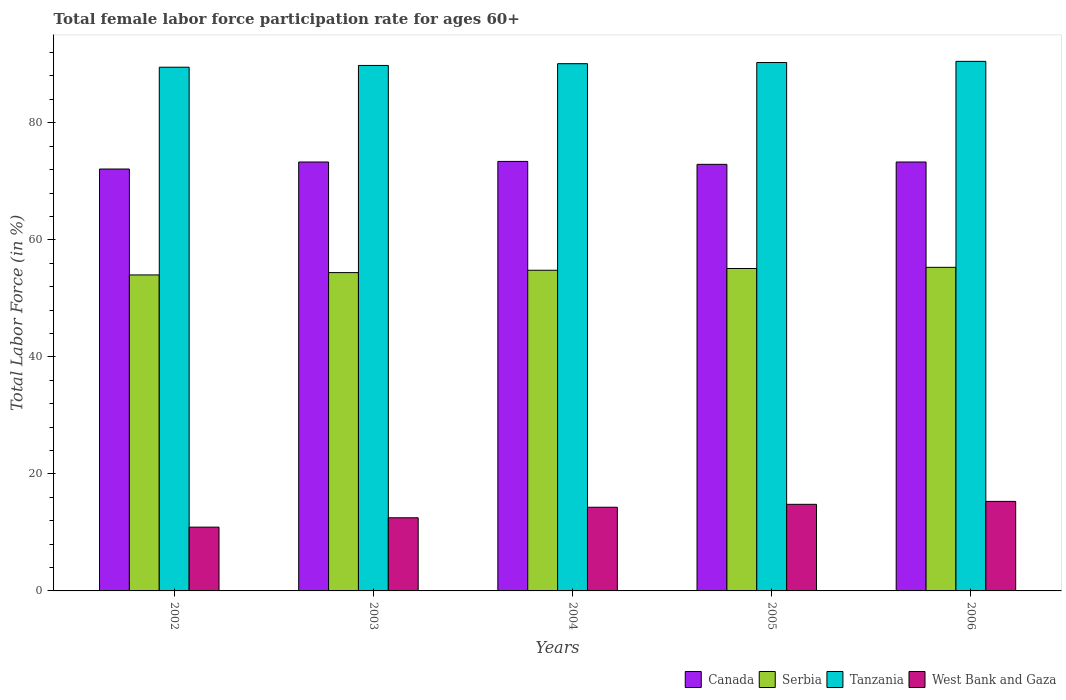How many different coloured bars are there?
Your answer should be very brief. 4. How many groups of bars are there?
Keep it short and to the point. 5. Are the number of bars per tick equal to the number of legend labels?
Provide a succinct answer. Yes. What is the label of the 2nd group of bars from the left?
Keep it short and to the point. 2003. What is the female labor force participation rate in Serbia in 2003?
Your answer should be compact. 54.4. Across all years, what is the maximum female labor force participation rate in Serbia?
Provide a short and direct response. 55.3. Across all years, what is the minimum female labor force participation rate in West Bank and Gaza?
Your response must be concise. 10.9. In which year was the female labor force participation rate in Canada maximum?
Make the answer very short. 2004. In which year was the female labor force participation rate in Serbia minimum?
Give a very brief answer. 2002. What is the total female labor force participation rate in West Bank and Gaza in the graph?
Make the answer very short. 67.8. What is the difference between the female labor force participation rate in West Bank and Gaza in 2004 and that in 2005?
Your response must be concise. -0.5. What is the difference between the female labor force participation rate in West Bank and Gaza in 2005 and the female labor force participation rate in Canada in 2004?
Ensure brevity in your answer.  -58.6. What is the average female labor force participation rate in Canada per year?
Offer a very short reply. 73. In the year 2005, what is the difference between the female labor force participation rate in Canada and female labor force participation rate in West Bank and Gaza?
Provide a succinct answer. 58.1. In how many years, is the female labor force participation rate in West Bank and Gaza greater than 88 %?
Provide a succinct answer. 0. What is the ratio of the female labor force participation rate in Serbia in 2003 to that in 2004?
Make the answer very short. 0.99. Is the difference between the female labor force participation rate in Canada in 2003 and 2005 greater than the difference between the female labor force participation rate in West Bank and Gaza in 2003 and 2005?
Keep it short and to the point. Yes. What is the difference between the highest and the second highest female labor force participation rate in Tanzania?
Make the answer very short. 0.2. What is the difference between the highest and the lowest female labor force participation rate in West Bank and Gaza?
Provide a succinct answer. 4.4. What does the 2nd bar from the left in 2002 represents?
Keep it short and to the point. Serbia. What does the 2nd bar from the right in 2006 represents?
Ensure brevity in your answer.  Tanzania. How many bars are there?
Your answer should be compact. 20. Are all the bars in the graph horizontal?
Your answer should be compact. No. How many years are there in the graph?
Provide a short and direct response. 5. Does the graph contain grids?
Offer a very short reply. No. What is the title of the graph?
Your answer should be very brief. Total female labor force participation rate for ages 60+. What is the label or title of the X-axis?
Your answer should be very brief. Years. What is the label or title of the Y-axis?
Your answer should be compact. Total Labor Force (in %). What is the Total Labor Force (in %) of Canada in 2002?
Your response must be concise. 72.1. What is the Total Labor Force (in %) of Serbia in 2002?
Your answer should be compact. 54. What is the Total Labor Force (in %) in Tanzania in 2002?
Ensure brevity in your answer.  89.5. What is the Total Labor Force (in %) in West Bank and Gaza in 2002?
Your response must be concise. 10.9. What is the Total Labor Force (in %) in Canada in 2003?
Your answer should be compact. 73.3. What is the Total Labor Force (in %) in Serbia in 2003?
Your answer should be compact. 54.4. What is the Total Labor Force (in %) of Tanzania in 2003?
Keep it short and to the point. 89.8. What is the Total Labor Force (in %) in West Bank and Gaza in 2003?
Make the answer very short. 12.5. What is the Total Labor Force (in %) of Canada in 2004?
Keep it short and to the point. 73.4. What is the Total Labor Force (in %) of Serbia in 2004?
Provide a short and direct response. 54.8. What is the Total Labor Force (in %) of Tanzania in 2004?
Make the answer very short. 90.1. What is the Total Labor Force (in %) in West Bank and Gaza in 2004?
Provide a short and direct response. 14.3. What is the Total Labor Force (in %) in Canada in 2005?
Keep it short and to the point. 72.9. What is the Total Labor Force (in %) of Serbia in 2005?
Offer a very short reply. 55.1. What is the Total Labor Force (in %) of Tanzania in 2005?
Keep it short and to the point. 90.3. What is the Total Labor Force (in %) of West Bank and Gaza in 2005?
Offer a terse response. 14.8. What is the Total Labor Force (in %) of Canada in 2006?
Your answer should be very brief. 73.3. What is the Total Labor Force (in %) in Serbia in 2006?
Make the answer very short. 55.3. What is the Total Labor Force (in %) in Tanzania in 2006?
Ensure brevity in your answer.  90.5. What is the Total Labor Force (in %) of West Bank and Gaza in 2006?
Ensure brevity in your answer.  15.3. Across all years, what is the maximum Total Labor Force (in %) of Canada?
Keep it short and to the point. 73.4. Across all years, what is the maximum Total Labor Force (in %) of Serbia?
Your answer should be very brief. 55.3. Across all years, what is the maximum Total Labor Force (in %) of Tanzania?
Offer a very short reply. 90.5. Across all years, what is the maximum Total Labor Force (in %) of West Bank and Gaza?
Provide a succinct answer. 15.3. Across all years, what is the minimum Total Labor Force (in %) in Canada?
Your response must be concise. 72.1. Across all years, what is the minimum Total Labor Force (in %) in Tanzania?
Your response must be concise. 89.5. Across all years, what is the minimum Total Labor Force (in %) of West Bank and Gaza?
Your response must be concise. 10.9. What is the total Total Labor Force (in %) in Canada in the graph?
Provide a short and direct response. 365. What is the total Total Labor Force (in %) in Serbia in the graph?
Provide a succinct answer. 273.6. What is the total Total Labor Force (in %) in Tanzania in the graph?
Provide a short and direct response. 450.2. What is the total Total Labor Force (in %) in West Bank and Gaza in the graph?
Your response must be concise. 67.8. What is the difference between the Total Labor Force (in %) in Tanzania in 2002 and that in 2003?
Make the answer very short. -0.3. What is the difference between the Total Labor Force (in %) in Serbia in 2002 and that in 2004?
Offer a terse response. -0.8. What is the difference between the Total Labor Force (in %) of West Bank and Gaza in 2002 and that in 2005?
Your response must be concise. -3.9. What is the difference between the Total Labor Force (in %) of Tanzania in 2002 and that in 2006?
Provide a succinct answer. -1. What is the difference between the Total Labor Force (in %) in West Bank and Gaza in 2002 and that in 2006?
Give a very brief answer. -4.4. What is the difference between the Total Labor Force (in %) in Canada in 2003 and that in 2004?
Give a very brief answer. -0.1. What is the difference between the Total Labor Force (in %) of Serbia in 2003 and that in 2004?
Make the answer very short. -0.4. What is the difference between the Total Labor Force (in %) of Canada in 2003 and that in 2005?
Make the answer very short. 0.4. What is the difference between the Total Labor Force (in %) in Serbia in 2003 and that in 2005?
Your answer should be compact. -0.7. What is the difference between the Total Labor Force (in %) of West Bank and Gaza in 2003 and that in 2006?
Provide a short and direct response. -2.8. What is the difference between the Total Labor Force (in %) in Canada in 2004 and that in 2005?
Keep it short and to the point. 0.5. What is the difference between the Total Labor Force (in %) in Tanzania in 2004 and that in 2005?
Keep it short and to the point. -0.2. What is the difference between the Total Labor Force (in %) in Serbia in 2004 and that in 2006?
Provide a short and direct response. -0.5. What is the difference between the Total Labor Force (in %) of Tanzania in 2004 and that in 2006?
Offer a very short reply. -0.4. What is the difference between the Total Labor Force (in %) of West Bank and Gaza in 2004 and that in 2006?
Your answer should be compact. -1. What is the difference between the Total Labor Force (in %) in Serbia in 2005 and that in 2006?
Offer a terse response. -0.2. What is the difference between the Total Labor Force (in %) in West Bank and Gaza in 2005 and that in 2006?
Offer a terse response. -0.5. What is the difference between the Total Labor Force (in %) of Canada in 2002 and the Total Labor Force (in %) of Tanzania in 2003?
Make the answer very short. -17.7. What is the difference between the Total Labor Force (in %) of Canada in 2002 and the Total Labor Force (in %) of West Bank and Gaza in 2003?
Offer a terse response. 59.6. What is the difference between the Total Labor Force (in %) of Serbia in 2002 and the Total Labor Force (in %) of Tanzania in 2003?
Your answer should be compact. -35.8. What is the difference between the Total Labor Force (in %) of Serbia in 2002 and the Total Labor Force (in %) of West Bank and Gaza in 2003?
Your answer should be very brief. 41.5. What is the difference between the Total Labor Force (in %) in Canada in 2002 and the Total Labor Force (in %) in Tanzania in 2004?
Give a very brief answer. -18. What is the difference between the Total Labor Force (in %) of Canada in 2002 and the Total Labor Force (in %) of West Bank and Gaza in 2004?
Your response must be concise. 57.8. What is the difference between the Total Labor Force (in %) of Serbia in 2002 and the Total Labor Force (in %) of Tanzania in 2004?
Your answer should be very brief. -36.1. What is the difference between the Total Labor Force (in %) in Serbia in 2002 and the Total Labor Force (in %) in West Bank and Gaza in 2004?
Your response must be concise. 39.7. What is the difference between the Total Labor Force (in %) of Tanzania in 2002 and the Total Labor Force (in %) of West Bank and Gaza in 2004?
Offer a terse response. 75.2. What is the difference between the Total Labor Force (in %) of Canada in 2002 and the Total Labor Force (in %) of Serbia in 2005?
Offer a terse response. 17. What is the difference between the Total Labor Force (in %) in Canada in 2002 and the Total Labor Force (in %) in Tanzania in 2005?
Your answer should be compact. -18.2. What is the difference between the Total Labor Force (in %) of Canada in 2002 and the Total Labor Force (in %) of West Bank and Gaza in 2005?
Provide a short and direct response. 57.3. What is the difference between the Total Labor Force (in %) of Serbia in 2002 and the Total Labor Force (in %) of Tanzania in 2005?
Your response must be concise. -36.3. What is the difference between the Total Labor Force (in %) of Serbia in 2002 and the Total Labor Force (in %) of West Bank and Gaza in 2005?
Keep it short and to the point. 39.2. What is the difference between the Total Labor Force (in %) of Tanzania in 2002 and the Total Labor Force (in %) of West Bank and Gaza in 2005?
Give a very brief answer. 74.7. What is the difference between the Total Labor Force (in %) of Canada in 2002 and the Total Labor Force (in %) of Tanzania in 2006?
Keep it short and to the point. -18.4. What is the difference between the Total Labor Force (in %) in Canada in 2002 and the Total Labor Force (in %) in West Bank and Gaza in 2006?
Your response must be concise. 56.8. What is the difference between the Total Labor Force (in %) in Serbia in 2002 and the Total Labor Force (in %) in Tanzania in 2006?
Your answer should be compact. -36.5. What is the difference between the Total Labor Force (in %) in Serbia in 2002 and the Total Labor Force (in %) in West Bank and Gaza in 2006?
Offer a terse response. 38.7. What is the difference between the Total Labor Force (in %) of Tanzania in 2002 and the Total Labor Force (in %) of West Bank and Gaza in 2006?
Ensure brevity in your answer.  74.2. What is the difference between the Total Labor Force (in %) of Canada in 2003 and the Total Labor Force (in %) of Serbia in 2004?
Make the answer very short. 18.5. What is the difference between the Total Labor Force (in %) in Canada in 2003 and the Total Labor Force (in %) in Tanzania in 2004?
Provide a succinct answer. -16.8. What is the difference between the Total Labor Force (in %) in Canada in 2003 and the Total Labor Force (in %) in West Bank and Gaza in 2004?
Ensure brevity in your answer.  59. What is the difference between the Total Labor Force (in %) in Serbia in 2003 and the Total Labor Force (in %) in Tanzania in 2004?
Make the answer very short. -35.7. What is the difference between the Total Labor Force (in %) of Serbia in 2003 and the Total Labor Force (in %) of West Bank and Gaza in 2004?
Your answer should be compact. 40.1. What is the difference between the Total Labor Force (in %) in Tanzania in 2003 and the Total Labor Force (in %) in West Bank and Gaza in 2004?
Ensure brevity in your answer.  75.5. What is the difference between the Total Labor Force (in %) in Canada in 2003 and the Total Labor Force (in %) in Serbia in 2005?
Provide a short and direct response. 18.2. What is the difference between the Total Labor Force (in %) in Canada in 2003 and the Total Labor Force (in %) in West Bank and Gaza in 2005?
Provide a short and direct response. 58.5. What is the difference between the Total Labor Force (in %) in Serbia in 2003 and the Total Labor Force (in %) in Tanzania in 2005?
Provide a succinct answer. -35.9. What is the difference between the Total Labor Force (in %) of Serbia in 2003 and the Total Labor Force (in %) of West Bank and Gaza in 2005?
Your response must be concise. 39.6. What is the difference between the Total Labor Force (in %) in Tanzania in 2003 and the Total Labor Force (in %) in West Bank and Gaza in 2005?
Offer a terse response. 75. What is the difference between the Total Labor Force (in %) in Canada in 2003 and the Total Labor Force (in %) in Tanzania in 2006?
Offer a very short reply. -17.2. What is the difference between the Total Labor Force (in %) of Serbia in 2003 and the Total Labor Force (in %) of Tanzania in 2006?
Keep it short and to the point. -36.1. What is the difference between the Total Labor Force (in %) of Serbia in 2003 and the Total Labor Force (in %) of West Bank and Gaza in 2006?
Give a very brief answer. 39.1. What is the difference between the Total Labor Force (in %) of Tanzania in 2003 and the Total Labor Force (in %) of West Bank and Gaza in 2006?
Make the answer very short. 74.5. What is the difference between the Total Labor Force (in %) of Canada in 2004 and the Total Labor Force (in %) of Serbia in 2005?
Your answer should be very brief. 18.3. What is the difference between the Total Labor Force (in %) of Canada in 2004 and the Total Labor Force (in %) of Tanzania in 2005?
Make the answer very short. -16.9. What is the difference between the Total Labor Force (in %) of Canada in 2004 and the Total Labor Force (in %) of West Bank and Gaza in 2005?
Give a very brief answer. 58.6. What is the difference between the Total Labor Force (in %) of Serbia in 2004 and the Total Labor Force (in %) of Tanzania in 2005?
Offer a terse response. -35.5. What is the difference between the Total Labor Force (in %) in Tanzania in 2004 and the Total Labor Force (in %) in West Bank and Gaza in 2005?
Offer a terse response. 75.3. What is the difference between the Total Labor Force (in %) in Canada in 2004 and the Total Labor Force (in %) in Tanzania in 2006?
Offer a terse response. -17.1. What is the difference between the Total Labor Force (in %) of Canada in 2004 and the Total Labor Force (in %) of West Bank and Gaza in 2006?
Your answer should be compact. 58.1. What is the difference between the Total Labor Force (in %) in Serbia in 2004 and the Total Labor Force (in %) in Tanzania in 2006?
Offer a very short reply. -35.7. What is the difference between the Total Labor Force (in %) in Serbia in 2004 and the Total Labor Force (in %) in West Bank and Gaza in 2006?
Your response must be concise. 39.5. What is the difference between the Total Labor Force (in %) in Tanzania in 2004 and the Total Labor Force (in %) in West Bank and Gaza in 2006?
Offer a very short reply. 74.8. What is the difference between the Total Labor Force (in %) in Canada in 2005 and the Total Labor Force (in %) in Tanzania in 2006?
Offer a terse response. -17.6. What is the difference between the Total Labor Force (in %) of Canada in 2005 and the Total Labor Force (in %) of West Bank and Gaza in 2006?
Your response must be concise. 57.6. What is the difference between the Total Labor Force (in %) of Serbia in 2005 and the Total Labor Force (in %) of Tanzania in 2006?
Offer a terse response. -35.4. What is the difference between the Total Labor Force (in %) in Serbia in 2005 and the Total Labor Force (in %) in West Bank and Gaza in 2006?
Make the answer very short. 39.8. What is the average Total Labor Force (in %) in Serbia per year?
Provide a succinct answer. 54.72. What is the average Total Labor Force (in %) in Tanzania per year?
Provide a succinct answer. 90.04. What is the average Total Labor Force (in %) in West Bank and Gaza per year?
Offer a terse response. 13.56. In the year 2002, what is the difference between the Total Labor Force (in %) of Canada and Total Labor Force (in %) of Tanzania?
Ensure brevity in your answer.  -17.4. In the year 2002, what is the difference between the Total Labor Force (in %) in Canada and Total Labor Force (in %) in West Bank and Gaza?
Offer a terse response. 61.2. In the year 2002, what is the difference between the Total Labor Force (in %) of Serbia and Total Labor Force (in %) of Tanzania?
Your response must be concise. -35.5. In the year 2002, what is the difference between the Total Labor Force (in %) of Serbia and Total Labor Force (in %) of West Bank and Gaza?
Offer a terse response. 43.1. In the year 2002, what is the difference between the Total Labor Force (in %) in Tanzania and Total Labor Force (in %) in West Bank and Gaza?
Your answer should be compact. 78.6. In the year 2003, what is the difference between the Total Labor Force (in %) of Canada and Total Labor Force (in %) of Serbia?
Provide a short and direct response. 18.9. In the year 2003, what is the difference between the Total Labor Force (in %) in Canada and Total Labor Force (in %) in Tanzania?
Keep it short and to the point. -16.5. In the year 2003, what is the difference between the Total Labor Force (in %) in Canada and Total Labor Force (in %) in West Bank and Gaza?
Offer a terse response. 60.8. In the year 2003, what is the difference between the Total Labor Force (in %) of Serbia and Total Labor Force (in %) of Tanzania?
Offer a very short reply. -35.4. In the year 2003, what is the difference between the Total Labor Force (in %) in Serbia and Total Labor Force (in %) in West Bank and Gaza?
Make the answer very short. 41.9. In the year 2003, what is the difference between the Total Labor Force (in %) in Tanzania and Total Labor Force (in %) in West Bank and Gaza?
Offer a terse response. 77.3. In the year 2004, what is the difference between the Total Labor Force (in %) in Canada and Total Labor Force (in %) in Serbia?
Offer a terse response. 18.6. In the year 2004, what is the difference between the Total Labor Force (in %) in Canada and Total Labor Force (in %) in Tanzania?
Your answer should be compact. -16.7. In the year 2004, what is the difference between the Total Labor Force (in %) in Canada and Total Labor Force (in %) in West Bank and Gaza?
Offer a terse response. 59.1. In the year 2004, what is the difference between the Total Labor Force (in %) of Serbia and Total Labor Force (in %) of Tanzania?
Offer a very short reply. -35.3. In the year 2004, what is the difference between the Total Labor Force (in %) of Serbia and Total Labor Force (in %) of West Bank and Gaza?
Your answer should be compact. 40.5. In the year 2004, what is the difference between the Total Labor Force (in %) in Tanzania and Total Labor Force (in %) in West Bank and Gaza?
Keep it short and to the point. 75.8. In the year 2005, what is the difference between the Total Labor Force (in %) of Canada and Total Labor Force (in %) of Tanzania?
Give a very brief answer. -17.4. In the year 2005, what is the difference between the Total Labor Force (in %) in Canada and Total Labor Force (in %) in West Bank and Gaza?
Keep it short and to the point. 58.1. In the year 2005, what is the difference between the Total Labor Force (in %) of Serbia and Total Labor Force (in %) of Tanzania?
Offer a very short reply. -35.2. In the year 2005, what is the difference between the Total Labor Force (in %) in Serbia and Total Labor Force (in %) in West Bank and Gaza?
Offer a terse response. 40.3. In the year 2005, what is the difference between the Total Labor Force (in %) in Tanzania and Total Labor Force (in %) in West Bank and Gaza?
Provide a short and direct response. 75.5. In the year 2006, what is the difference between the Total Labor Force (in %) of Canada and Total Labor Force (in %) of Tanzania?
Make the answer very short. -17.2. In the year 2006, what is the difference between the Total Labor Force (in %) of Serbia and Total Labor Force (in %) of Tanzania?
Your answer should be compact. -35.2. In the year 2006, what is the difference between the Total Labor Force (in %) of Serbia and Total Labor Force (in %) of West Bank and Gaza?
Offer a very short reply. 40. In the year 2006, what is the difference between the Total Labor Force (in %) in Tanzania and Total Labor Force (in %) in West Bank and Gaza?
Keep it short and to the point. 75.2. What is the ratio of the Total Labor Force (in %) in Canada in 2002 to that in 2003?
Provide a succinct answer. 0.98. What is the ratio of the Total Labor Force (in %) in Serbia in 2002 to that in 2003?
Provide a short and direct response. 0.99. What is the ratio of the Total Labor Force (in %) in Tanzania in 2002 to that in 2003?
Your response must be concise. 1. What is the ratio of the Total Labor Force (in %) of West Bank and Gaza in 2002 to that in 2003?
Offer a very short reply. 0.87. What is the ratio of the Total Labor Force (in %) in Canada in 2002 to that in 2004?
Offer a very short reply. 0.98. What is the ratio of the Total Labor Force (in %) of Serbia in 2002 to that in 2004?
Your response must be concise. 0.99. What is the ratio of the Total Labor Force (in %) in West Bank and Gaza in 2002 to that in 2004?
Your answer should be compact. 0.76. What is the ratio of the Total Labor Force (in %) of West Bank and Gaza in 2002 to that in 2005?
Make the answer very short. 0.74. What is the ratio of the Total Labor Force (in %) in Canada in 2002 to that in 2006?
Make the answer very short. 0.98. What is the ratio of the Total Labor Force (in %) of Serbia in 2002 to that in 2006?
Your answer should be compact. 0.98. What is the ratio of the Total Labor Force (in %) of Tanzania in 2002 to that in 2006?
Offer a very short reply. 0.99. What is the ratio of the Total Labor Force (in %) of West Bank and Gaza in 2002 to that in 2006?
Your answer should be compact. 0.71. What is the ratio of the Total Labor Force (in %) of Tanzania in 2003 to that in 2004?
Offer a terse response. 1. What is the ratio of the Total Labor Force (in %) of West Bank and Gaza in 2003 to that in 2004?
Keep it short and to the point. 0.87. What is the ratio of the Total Labor Force (in %) of Canada in 2003 to that in 2005?
Ensure brevity in your answer.  1.01. What is the ratio of the Total Labor Force (in %) in Serbia in 2003 to that in 2005?
Offer a very short reply. 0.99. What is the ratio of the Total Labor Force (in %) in West Bank and Gaza in 2003 to that in 2005?
Offer a terse response. 0.84. What is the ratio of the Total Labor Force (in %) in Canada in 2003 to that in 2006?
Make the answer very short. 1. What is the ratio of the Total Labor Force (in %) of Serbia in 2003 to that in 2006?
Ensure brevity in your answer.  0.98. What is the ratio of the Total Labor Force (in %) of West Bank and Gaza in 2003 to that in 2006?
Provide a short and direct response. 0.82. What is the ratio of the Total Labor Force (in %) in Canada in 2004 to that in 2005?
Ensure brevity in your answer.  1.01. What is the ratio of the Total Labor Force (in %) of Serbia in 2004 to that in 2005?
Your response must be concise. 0.99. What is the ratio of the Total Labor Force (in %) in Tanzania in 2004 to that in 2005?
Offer a terse response. 1. What is the ratio of the Total Labor Force (in %) of West Bank and Gaza in 2004 to that in 2005?
Make the answer very short. 0.97. What is the ratio of the Total Labor Force (in %) of West Bank and Gaza in 2004 to that in 2006?
Your answer should be compact. 0.93. What is the ratio of the Total Labor Force (in %) of Serbia in 2005 to that in 2006?
Offer a terse response. 1. What is the ratio of the Total Labor Force (in %) in West Bank and Gaza in 2005 to that in 2006?
Provide a short and direct response. 0.97. What is the difference between the highest and the second highest Total Labor Force (in %) of Serbia?
Your answer should be very brief. 0.2. What is the difference between the highest and the second highest Total Labor Force (in %) of Tanzania?
Keep it short and to the point. 0.2. What is the difference between the highest and the lowest Total Labor Force (in %) in Canada?
Provide a short and direct response. 1.3. What is the difference between the highest and the lowest Total Labor Force (in %) in Serbia?
Offer a terse response. 1.3. What is the difference between the highest and the lowest Total Labor Force (in %) of Tanzania?
Offer a very short reply. 1. 